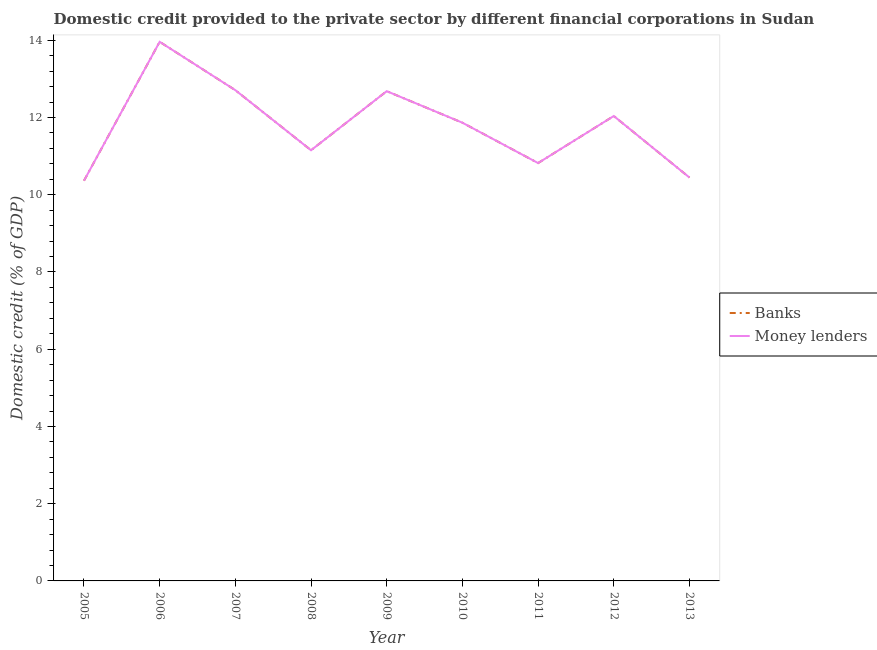How many different coloured lines are there?
Provide a short and direct response. 2. Is the number of lines equal to the number of legend labels?
Give a very brief answer. Yes. What is the domestic credit provided by banks in 2007?
Your answer should be very brief. 12.71. Across all years, what is the maximum domestic credit provided by money lenders?
Your answer should be compact. 13.96. Across all years, what is the minimum domestic credit provided by banks?
Your response must be concise. 10.36. In which year was the domestic credit provided by banks maximum?
Your answer should be very brief. 2006. What is the total domestic credit provided by money lenders in the graph?
Your response must be concise. 106.04. What is the difference between the domestic credit provided by money lenders in 2008 and that in 2012?
Make the answer very short. -0.89. What is the difference between the domestic credit provided by money lenders in 2009 and the domestic credit provided by banks in 2007?
Ensure brevity in your answer.  -0.03. What is the average domestic credit provided by banks per year?
Give a very brief answer. 11.78. In how many years, is the domestic credit provided by money lenders greater than 13.2 %?
Provide a succinct answer. 1. What is the ratio of the domestic credit provided by banks in 2005 to that in 2013?
Provide a short and direct response. 0.99. Is the difference between the domestic credit provided by banks in 2005 and 2013 greater than the difference between the domestic credit provided by money lenders in 2005 and 2013?
Provide a short and direct response. No. What is the difference between the highest and the second highest domestic credit provided by banks?
Make the answer very short. 1.25. What is the difference between the highest and the lowest domestic credit provided by banks?
Ensure brevity in your answer.  3.6. Is the sum of the domestic credit provided by money lenders in 2005 and 2011 greater than the maximum domestic credit provided by banks across all years?
Your answer should be very brief. Yes. Does the domestic credit provided by banks monotonically increase over the years?
Your response must be concise. No. Is the domestic credit provided by banks strictly greater than the domestic credit provided by money lenders over the years?
Offer a terse response. No. Is the domestic credit provided by banks strictly less than the domestic credit provided by money lenders over the years?
Provide a succinct answer. No. How many years are there in the graph?
Your response must be concise. 9. What is the difference between two consecutive major ticks on the Y-axis?
Give a very brief answer. 2. Does the graph contain any zero values?
Offer a terse response. No. Does the graph contain grids?
Make the answer very short. No. Where does the legend appear in the graph?
Offer a very short reply. Center right. What is the title of the graph?
Your answer should be very brief. Domestic credit provided to the private sector by different financial corporations in Sudan. Does "Methane emissions" appear as one of the legend labels in the graph?
Offer a terse response. No. What is the label or title of the Y-axis?
Offer a terse response. Domestic credit (% of GDP). What is the Domestic credit (% of GDP) in Banks in 2005?
Ensure brevity in your answer.  10.36. What is the Domestic credit (% of GDP) in Money lenders in 2005?
Keep it short and to the point. 10.36. What is the Domestic credit (% of GDP) of Banks in 2006?
Ensure brevity in your answer.  13.96. What is the Domestic credit (% of GDP) in Money lenders in 2006?
Provide a succinct answer. 13.96. What is the Domestic credit (% of GDP) of Banks in 2007?
Your response must be concise. 12.71. What is the Domestic credit (% of GDP) of Money lenders in 2007?
Ensure brevity in your answer.  12.71. What is the Domestic credit (% of GDP) of Banks in 2008?
Provide a succinct answer. 11.15. What is the Domestic credit (% of GDP) of Money lenders in 2008?
Provide a short and direct response. 11.15. What is the Domestic credit (% of GDP) of Banks in 2009?
Your response must be concise. 12.68. What is the Domestic credit (% of GDP) of Money lenders in 2009?
Provide a short and direct response. 12.68. What is the Domestic credit (% of GDP) in Banks in 2010?
Offer a terse response. 11.87. What is the Domestic credit (% of GDP) in Money lenders in 2010?
Offer a very short reply. 11.87. What is the Domestic credit (% of GDP) of Banks in 2011?
Your response must be concise. 10.82. What is the Domestic credit (% of GDP) in Money lenders in 2011?
Make the answer very short. 10.82. What is the Domestic credit (% of GDP) of Banks in 2012?
Keep it short and to the point. 12.04. What is the Domestic credit (% of GDP) of Money lenders in 2012?
Your answer should be very brief. 12.04. What is the Domestic credit (% of GDP) in Banks in 2013?
Offer a terse response. 10.45. What is the Domestic credit (% of GDP) in Money lenders in 2013?
Make the answer very short. 10.45. Across all years, what is the maximum Domestic credit (% of GDP) of Banks?
Make the answer very short. 13.96. Across all years, what is the maximum Domestic credit (% of GDP) in Money lenders?
Make the answer very short. 13.96. Across all years, what is the minimum Domestic credit (% of GDP) in Banks?
Your response must be concise. 10.36. Across all years, what is the minimum Domestic credit (% of GDP) of Money lenders?
Offer a terse response. 10.36. What is the total Domestic credit (% of GDP) of Banks in the graph?
Ensure brevity in your answer.  106.04. What is the total Domestic credit (% of GDP) of Money lenders in the graph?
Offer a very short reply. 106.04. What is the difference between the Domestic credit (% of GDP) in Banks in 2005 and that in 2006?
Your response must be concise. -3.6. What is the difference between the Domestic credit (% of GDP) of Money lenders in 2005 and that in 2006?
Offer a very short reply. -3.6. What is the difference between the Domestic credit (% of GDP) of Banks in 2005 and that in 2007?
Your answer should be compact. -2.34. What is the difference between the Domestic credit (% of GDP) of Money lenders in 2005 and that in 2007?
Offer a very short reply. -2.34. What is the difference between the Domestic credit (% of GDP) of Banks in 2005 and that in 2008?
Your answer should be very brief. -0.79. What is the difference between the Domestic credit (% of GDP) of Money lenders in 2005 and that in 2008?
Give a very brief answer. -0.79. What is the difference between the Domestic credit (% of GDP) of Banks in 2005 and that in 2009?
Give a very brief answer. -2.32. What is the difference between the Domestic credit (% of GDP) of Money lenders in 2005 and that in 2009?
Your response must be concise. -2.32. What is the difference between the Domestic credit (% of GDP) of Banks in 2005 and that in 2010?
Make the answer very short. -1.5. What is the difference between the Domestic credit (% of GDP) of Money lenders in 2005 and that in 2010?
Keep it short and to the point. -1.5. What is the difference between the Domestic credit (% of GDP) in Banks in 2005 and that in 2011?
Keep it short and to the point. -0.46. What is the difference between the Domestic credit (% of GDP) of Money lenders in 2005 and that in 2011?
Keep it short and to the point. -0.46. What is the difference between the Domestic credit (% of GDP) of Banks in 2005 and that in 2012?
Ensure brevity in your answer.  -1.68. What is the difference between the Domestic credit (% of GDP) of Money lenders in 2005 and that in 2012?
Ensure brevity in your answer.  -1.68. What is the difference between the Domestic credit (% of GDP) in Banks in 2005 and that in 2013?
Make the answer very short. -0.08. What is the difference between the Domestic credit (% of GDP) in Money lenders in 2005 and that in 2013?
Offer a very short reply. -0.08. What is the difference between the Domestic credit (% of GDP) of Banks in 2006 and that in 2007?
Your answer should be compact. 1.25. What is the difference between the Domestic credit (% of GDP) of Money lenders in 2006 and that in 2007?
Your response must be concise. 1.25. What is the difference between the Domestic credit (% of GDP) in Banks in 2006 and that in 2008?
Offer a terse response. 2.81. What is the difference between the Domestic credit (% of GDP) in Money lenders in 2006 and that in 2008?
Ensure brevity in your answer.  2.81. What is the difference between the Domestic credit (% of GDP) of Banks in 2006 and that in 2009?
Keep it short and to the point. 1.28. What is the difference between the Domestic credit (% of GDP) in Money lenders in 2006 and that in 2009?
Your answer should be compact. 1.28. What is the difference between the Domestic credit (% of GDP) in Banks in 2006 and that in 2010?
Give a very brief answer. 2.09. What is the difference between the Domestic credit (% of GDP) of Money lenders in 2006 and that in 2010?
Provide a short and direct response. 2.09. What is the difference between the Domestic credit (% of GDP) in Banks in 2006 and that in 2011?
Your response must be concise. 3.14. What is the difference between the Domestic credit (% of GDP) of Money lenders in 2006 and that in 2011?
Keep it short and to the point. 3.14. What is the difference between the Domestic credit (% of GDP) in Banks in 2006 and that in 2012?
Your response must be concise. 1.92. What is the difference between the Domestic credit (% of GDP) in Money lenders in 2006 and that in 2012?
Offer a very short reply. 1.92. What is the difference between the Domestic credit (% of GDP) of Banks in 2006 and that in 2013?
Make the answer very short. 3.51. What is the difference between the Domestic credit (% of GDP) of Money lenders in 2006 and that in 2013?
Provide a short and direct response. 3.51. What is the difference between the Domestic credit (% of GDP) in Banks in 2007 and that in 2008?
Provide a short and direct response. 1.56. What is the difference between the Domestic credit (% of GDP) of Money lenders in 2007 and that in 2008?
Provide a succinct answer. 1.56. What is the difference between the Domestic credit (% of GDP) of Banks in 2007 and that in 2009?
Offer a terse response. 0.03. What is the difference between the Domestic credit (% of GDP) of Money lenders in 2007 and that in 2009?
Provide a short and direct response. 0.03. What is the difference between the Domestic credit (% of GDP) of Banks in 2007 and that in 2010?
Ensure brevity in your answer.  0.84. What is the difference between the Domestic credit (% of GDP) in Money lenders in 2007 and that in 2010?
Ensure brevity in your answer.  0.84. What is the difference between the Domestic credit (% of GDP) of Banks in 2007 and that in 2011?
Provide a succinct answer. 1.89. What is the difference between the Domestic credit (% of GDP) of Money lenders in 2007 and that in 2011?
Provide a short and direct response. 1.89. What is the difference between the Domestic credit (% of GDP) in Banks in 2007 and that in 2012?
Provide a short and direct response. 0.67. What is the difference between the Domestic credit (% of GDP) in Money lenders in 2007 and that in 2012?
Offer a terse response. 0.67. What is the difference between the Domestic credit (% of GDP) of Banks in 2007 and that in 2013?
Offer a terse response. 2.26. What is the difference between the Domestic credit (% of GDP) of Money lenders in 2007 and that in 2013?
Offer a very short reply. 2.26. What is the difference between the Domestic credit (% of GDP) in Banks in 2008 and that in 2009?
Your response must be concise. -1.53. What is the difference between the Domestic credit (% of GDP) in Money lenders in 2008 and that in 2009?
Offer a terse response. -1.53. What is the difference between the Domestic credit (% of GDP) of Banks in 2008 and that in 2010?
Make the answer very short. -0.71. What is the difference between the Domestic credit (% of GDP) of Money lenders in 2008 and that in 2010?
Your answer should be very brief. -0.71. What is the difference between the Domestic credit (% of GDP) in Banks in 2008 and that in 2011?
Make the answer very short. 0.33. What is the difference between the Domestic credit (% of GDP) of Money lenders in 2008 and that in 2011?
Keep it short and to the point. 0.33. What is the difference between the Domestic credit (% of GDP) in Banks in 2008 and that in 2012?
Your answer should be very brief. -0.89. What is the difference between the Domestic credit (% of GDP) of Money lenders in 2008 and that in 2012?
Offer a terse response. -0.89. What is the difference between the Domestic credit (% of GDP) of Banks in 2008 and that in 2013?
Provide a short and direct response. 0.71. What is the difference between the Domestic credit (% of GDP) of Money lenders in 2008 and that in 2013?
Your answer should be very brief. 0.71. What is the difference between the Domestic credit (% of GDP) of Banks in 2009 and that in 2010?
Make the answer very short. 0.82. What is the difference between the Domestic credit (% of GDP) of Money lenders in 2009 and that in 2010?
Provide a succinct answer. 0.82. What is the difference between the Domestic credit (% of GDP) in Banks in 2009 and that in 2011?
Your answer should be very brief. 1.86. What is the difference between the Domestic credit (% of GDP) in Money lenders in 2009 and that in 2011?
Your answer should be very brief. 1.86. What is the difference between the Domestic credit (% of GDP) of Banks in 2009 and that in 2012?
Your response must be concise. 0.64. What is the difference between the Domestic credit (% of GDP) in Money lenders in 2009 and that in 2012?
Make the answer very short. 0.64. What is the difference between the Domestic credit (% of GDP) of Banks in 2009 and that in 2013?
Provide a short and direct response. 2.24. What is the difference between the Domestic credit (% of GDP) in Money lenders in 2009 and that in 2013?
Your answer should be very brief. 2.24. What is the difference between the Domestic credit (% of GDP) of Banks in 2010 and that in 2011?
Your response must be concise. 1.04. What is the difference between the Domestic credit (% of GDP) of Money lenders in 2010 and that in 2011?
Give a very brief answer. 1.04. What is the difference between the Domestic credit (% of GDP) of Banks in 2010 and that in 2012?
Give a very brief answer. -0.17. What is the difference between the Domestic credit (% of GDP) in Money lenders in 2010 and that in 2012?
Make the answer very short. -0.17. What is the difference between the Domestic credit (% of GDP) of Banks in 2010 and that in 2013?
Keep it short and to the point. 1.42. What is the difference between the Domestic credit (% of GDP) of Money lenders in 2010 and that in 2013?
Keep it short and to the point. 1.42. What is the difference between the Domestic credit (% of GDP) in Banks in 2011 and that in 2012?
Provide a short and direct response. -1.22. What is the difference between the Domestic credit (% of GDP) in Money lenders in 2011 and that in 2012?
Offer a terse response. -1.22. What is the difference between the Domestic credit (% of GDP) in Banks in 2011 and that in 2013?
Offer a very short reply. 0.37. What is the difference between the Domestic credit (% of GDP) of Money lenders in 2011 and that in 2013?
Provide a short and direct response. 0.37. What is the difference between the Domestic credit (% of GDP) in Banks in 2012 and that in 2013?
Provide a short and direct response. 1.59. What is the difference between the Domestic credit (% of GDP) in Money lenders in 2012 and that in 2013?
Offer a very short reply. 1.59. What is the difference between the Domestic credit (% of GDP) of Banks in 2005 and the Domestic credit (% of GDP) of Money lenders in 2006?
Give a very brief answer. -3.6. What is the difference between the Domestic credit (% of GDP) of Banks in 2005 and the Domestic credit (% of GDP) of Money lenders in 2007?
Offer a very short reply. -2.34. What is the difference between the Domestic credit (% of GDP) of Banks in 2005 and the Domestic credit (% of GDP) of Money lenders in 2008?
Make the answer very short. -0.79. What is the difference between the Domestic credit (% of GDP) in Banks in 2005 and the Domestic credit (% of GDP) in Money lenders in 2009?
Make the answer very short. -2.32. What is the difference between the Domestic credit (% of GDP) of Banks in 2005 and the Domestic credit (% of GDP) of Money lenders in 2010?
Ensure brevity in your answer.  -1.5. What is the difference between the Domestic credit (% of GDP) in Banks in 2005 and the Domestic credit (% of GDP) in Money lenders in 2011?
Your response must be concise. -0.46. What is the difference between the Domestic credit (% of GDP) of Banks in 2005 and the Domestic credit (% of GDP) of Money lenders in 2012?
Offer a terse response. -1.68. What is the difference between the Domestic credit (% of GDP) of Banks in 2005 and the Domestic credit (% of GDP) of Money lenders in 2013?
Give a very brief answer. -0.08. What is the difference between the Domestic credit (% of GDP) in Banks in 2006 and the Domestic credit (% of GDP) in Money lenders in 2007?
Your answer should be compact. 1.25. What is the difference between the Domestic credit (% of GDP) of Banks in 2006 and the Domestic credit (% of GDP) of Money lenders in 2008?
Your response must be concise. 2.81. What is the difference between the Domestic credit (% of GDP) in Banks in 2006 and the Domestic credit (% of GDP) in Money lenders in 2009?
Your answer should be very brief. 1.28. What is the difference between the Domestic credit (% of GDP) in Banks in 2006 and the Domestic credit (% of GDP) in Money lenders in 2010?
Give a very brief answer. 2.09. What is the difference between the Domestic credit (% of GDP) in Banks in 2006 and the Domestic credit (% of GDP) in Money lenders in 2011?
Offer a very short reply. 3.14. What is the difference between the Domestic credit (% of GDP) of Banks in 2006 and the Domestic credit (% of GDP) of Money lenders in 2012?
Your response must be concise. 1.92. What is the difference between the Domestic credit (% of GDP) of Banks in 2006 and the Domestic credit (% of GDP) of Money lenders in 2013?
Keep it short and to the point. 3.51. What is the difference between the Domestic credit (% of GDP) in Banks in 2007 and the Domestic credit (% of GDP) in Money lenders in 2008?
Ensure brevity in your answer.  1.56. What is the difference between the Domestic credit (% of GDP) in Banks in 2007 and the Domestic credit (% of GDP) in Money lenders in 2009?
Ensure brevity in your answer.  0.03. What is the difference between the Domestic credit (% of GDP) of Banks in 2007 and the Domestic credit (% of GDP) of Money lenders in 2010?
Your answer should be very brief. 0.84. What is the difference between the Domestic credit (% of GDP) in Banks in 2007 and the Domestic credit (% of GDP) in Money lenders in 2011?
Your response must be concise. 1.89. What is the difference between the Domestic credit (% of GDP) of Banks in 2007 and the Domestic credit (% of GDP) of Money lenders in 2012?
Your response must be concise. 0.67. What is the difference between the Domestic credit (% of GDP) in Banks in 2007 and the Domestic credit (% of GDP) in Money lenders in 2013?
Provide a short and direct response. 2.26. What is the difference between the Domestic credit (% of GDP) in Banks in 2008 and the Domestic credit (% of GDP) in Money lenders in 2009?
Offer a very short reply. -1.53. What is the difference between the Domestic credit (% of GDP) of Banks in 2008 and the Domestic credit (% of GDP) of Money lenders in 2010?
Your answer should be compact. -0.71. What is the difference between the Domestic credit (% of GDP) of Banks in 2008 and the Domestic credit (% of GDP) of Money lenders in 2011?
Keep it short and to the point. 0.33. What is the difference between the Domestic credit (% of GDP) of Banks in 2008 and the Domestic credit (% of GDP) of Money lenders in 2012?
Offer a terse response. -0.89. What is the difference between the Domestic credit (% of GDP) of Banks in 2008 and the Domestic credit (% of GDP) of Money lenders in 2013?
Give a very brief answer. 0.71. What is the difference between the Domestic credit (% of GDP) in Banks in 2009 and the Domestic credit (% of GDP) in Money lenders in 2010?
Offer a terse response. 0.82. What is the difference between the Domestic credit (% of GDP) in Banks in 2009 and the Domestic credit (% of GDP) in Money lenders in 2011?
Provide a succinct answer. 1.86. What is the difference between the Domestic credit (% of GDP) of Banks in 2009 and the Domestic credit (% of GDP) of Money lenders in 2012?
Provide a succinct answer. 0.64. What is the difference between the Domestic credit (% of GDP) of Banks in 2009 and the Domestic credit (% of GDP) of Money lenders in 2013?
Your answer should be very brief. 2.24. What is the difference between the Domestic credit (% of GDP) in Banks in 2010 and the Domestic credit (% of GDP) in Money lenders in 2011?
Keep it short and to the point. 1.04. What is the difference between the Domestic credit (% of GDP) of Banks in 2010 and the Domestic credit (% of GDP) of Money lenders in 2012?
Provide a short and direct response. -0.17. What is the difference between the Domestic credit (% of GDP) in Banks in 2010 and the Domestic credit (% of GDP) in Money lenders in 2013?
Keep it short and to the point. 1.42. What is the difference between the Domestic credit (% of GDP) of Banks in 2011 and the Domestic credit (% of GDP) of Money lenders in 2012?
Provide a succinct answer. -1.22. What is the difference between the Domestic credit (% of GDP) in Banks in 2011 and the Domestic credit (% of GDP) in Money lenders in 2013?
Your answer should be compact. 0.37. What is the difference between the Domestic credit (% of GDP) of Banks in 2012 and the Domestic credit (% of GDP) of Money lenders in 2013?
Offer a very short reply. 1.59. What is the average Domestic credit (% of GDP) in Banks per year?
Your response must be concise. 11.78. What is the average Domestic credit (% of GDP) in Money lenders per year?
Provide a short and direct response. 11.78. In the year 2005, what is the difference between the Domestic credit (% of GDP) in Banks and Domestic credit (% of GDP) in Money lenders?
Your answer should be compact. 0. In the year 2007, what is the difference between the Domestic credit (% of GDP) of Banks and Domestic credit (% of GDP) of Money lenders?
Ensure brevity in your answer.  0. In the year 2008, what is the difference between the Domestic credit (% of GDP) in Banks and Domestic credit (% of GDP) in Money lenders?
Your answer should be very brief. 0. In the year 2011, what is the difference between the Domestic credit (% of GDP) in Banks and Domestic credit (% of GDP) in Money lenders?
Ensure brevity in your answer.  0. What is the ratio of the Domestic credit (% of GDP) of Banks in 2005 to that in 2006?
Provide a short and direct response. 0.74. What is the ratio of the Domestic credit (% of GDP) in Money lenders in 2005 to that in 2006?
Give a very brief answer. 0.74. What is the ratio of the Domestic credit (% of GDP) in Banks in 2005 to that in 2007?
Ensure brevity in your answer.  0.82. What is the ratio of the Domestic credit (% of GDP) in Money lenders in 2005 to that in 2007?
Your answer should be very brief. 0.82. What is the ratio of the Domestic credit (% of GDP) of Banks in 2005 to that in 2008?
Your answer should be very brief. 0.93. What is the ratio of the Domestic credit (% of GDP) of Money lenders in 2005 to that in 2008?
Your answer should be very brief. 0.93. What is the ratio of the Domestic credit (% of GDP) of Banks in 2005 to that in 2009?
Your response must be concise. 0.82. What is the ratio of the Domestic credit (% of GDP) in Money lenders in 2005 to that in 2009?
Your answer should be very brief. 0.82. What is the ratio of the Domestic credit (% of GDP) of Banks in 2005 to that in 2010?
Make the answer very short. 0.87. What is the ratio of the Domestic credit (% of GDP) in Money lenders in 2005 to that in 2010?
Your response must be concise. 0.87. What is the ratio of the Domestic credit (% of GDP) of Banks in 2005 to that in 2011?
Make the answer very short. 0.96. What is the ratio of the Domestic credit (% of GDP) of Money lenders in 2005 to that in 2011?
Provide a succinct answer. 0.96. What is the ratio of the Domestic credit (% of GDP) in Banks in 2005 to that in 2012?
Give a very brief answer. 0.86. What is the ratio of the Domestic credit (% of GDP) of Money lenders in 2005 to that in 2012?
Make the answer very short. 0.86. What is the ratio of the Domestic credit (% of GDP) in Money lenders in 2005 to that in 2013?
Make the answer very short. 0.99. What is the ratio of the Domestic credit (% of GDP) in Banks in 2006 to that in 2007?
Keep it short and to the point. 1.1. What is the ratio of the Domestic credit (% of GDP) in Money lenders in 2006 to that in 2007?
Provide a short and direct response. 1.1. What is the ratio of the Domestic credit (% of GDP) in Banks in 2006 to that in 2008?
Keep it short and to the point. 1.25. What is the ratio of the Domestic credit (% of GDP) in Money lenders in 2006 to that in 2008?
Keep it short and to the point. 1.25. What is the ratio of the Domestic credit (% of GDP) in Banks in 2006 to that in 2009?
Give a very brief answer. 1.1. What is the ratio of the Domestic credit (% of GDP) in Money lenders in 2006 to that in 2009?
Give a very brief answer. 1.1. What is the ratio of the Domestic credit (% of GDP) of Banks in 2006 to that in 2010?
Provide a short and direct response. 1.18. What is the ratio of the Domestic credit (% of GDP) in Money lenders in 2006 to that in 2010?
Your answer should be very brief. 1.18. What is the ratio of the Domestic credit (% of GDP) in Banks in 2006 to that in 2011?
Keep it short and to the point. 1.29. What is the ratio of the Domestic credit (% of GDP) of Money lenders in 2006 to that in 2011?
Your answer should be very brief. 1.29. What is the ratio of the Domestic credit (% of GDP) in Banks in 2006 to that in 2012?
Your response must be concise. 1.16. What is the ratio of the Domestic credit (% of GDP) of Money lenders in 2006 to that in 2012?
Give a very brief answer. 1.16. What is the ratio of the Domestic credit (% of GDP) of Banks in 2006 to that in 2013?
Keep it short and to the point. 1.34. What is the ratio of the Domestic credit (% of GDP) in Money lenders in 2006 to that in 2013?
Offer a very short reply. 1.34. What is the ratio of the Domestic credit (% of GDP) in Banks in 2007 to that in 2008?
Your answer should be compact. 1.14. What is the ratio of the Domestic credit (% of GDP) of Money lenders in 2007 to that in 2008?
Provide a short and direct response. 1.14. What is the ratio of the Domestic credit (% of GDP) of Money lenders in 2007 to that in 2009?
Give a very brief answer. 1. What is the ratio of the Domestic credit (% of GDP) in Banks in 2007 to that in 2010?
Your answer should be very brief. 1.07. What is the ratio of the Domestic credit (% of GDP) in Money lenders in 2007 to that in 2010?
Provide a short and direct response. 1.07. What is the ratio of the Domestic credit (% of GDP) of Banks in 2007 to that in 2011?
Ensure brevity in your answer.  1.17. What is the ratio of the Domestic credit (% of GDP) of Money lenders in 2007 to that in 2011?
Provide a short and direct response. 1.17. What is the ratio of the Domestic credit (% of GDP) of Banks in 2007 to that in 2012?
Offer a very short reply. 1.06. What is the ratio of the Domestic credit (% of GDP) in Money lenders in 2007 to that in 2012?
Keep it short and to the point. 1.06. What is the ratio of the Domestic credit (% of GDP) in Banks in 2007 to that in 2013?
Your response must be concise. 1.22. What is the ratio of the Domestic credit (% of GDP) in Money lenders in 2007 to that in 2013?
Your answer should be compact. 1.22. What is the ratio of the Domestic credit (% of GDP) of Banks in 2008 to that in 2009?
Your answer should be very brief. 0.88. What is the ratio of the Domestic credit (% of GDP) of Money lenders in 2008 to that in 2009?
Keep it short and to the point. 0.88. What is the ratio of the Domestic credit (% of GDP) in Banks in 2008 to that in 2010?
Offer a very short reply. 0.94. What is the ratio of the Domestic credit (% of GDP) in Money lenders in 2008 to that in 2010?
Offer a very short reply. 0.94. What is the ratio of the Domestic credit (% of GDP) in Banks in 2008 to that in 2011?
Offer a very short reply. 1.03. What is the ratio of the Domestic credit (% of GDP) in Money lenders in 2008 to that in 2011?
Keep it short and to the point. 1.03. What is the ratio of the Domestic credit (% of GDP) of Banks in 2008 to that in 2012?
Your answer should be very brief. 0.93. What is the ratio of the Domestic credit (% of GDP) in Money lenders in 2008 to that in 2012?
Offer a very short reply. 0.93. What is the ratio of the Domestic credit (% of GDP) of Banks in 2008 to that in 2013?
Your answer should be compact. 1.07. What is the ratio of the Domestic credit (% of GDP) in Money lenders in 2008 to that in 2013?
Offer a very short reply. 1.07. What is the ratio of the Domestic credit (% of GDP) in Banks in 2009 to that in 2010?
Give a very brief answer. 1.07. What is the ratio of the Domestic credit (% of GDP) in Money lenders in 2009 to that in 2010?
Ensure brevity in your answer.  1.07. What is the ratio of the Domestic credit (% of GDP) in Banks in 2009 to that in 2011?
Give a very brief answer. 1.17. What is the ratio of the Domestic credit (% of GDP) in Money lenders in 2009 to that in 2011?
Your answer should be very brief. 1.17. What is the ratio of the Domestic credit (% of GDP) in Banks in 2009 to that in 2012?
Your answer should be compact. 1.05. What is the ratio of the Domestic credit (% of GDP) of Money lenders in 2009 to that in 2012?
Your answer should be very brief. 1.05. What is the ratio of the Domestic credit (% of GDP) of Banks in 2009 to that in 2013?
Offer a very short reply. 1.21. What is the ratio of the Domestic credit (% of GDP) in Money lenders in 2009 to that in 2013?
Provide a succinct answer. 1.21. What is the ratio of the Domestic credit (% of GDP) in Banks in 2010 to that in 2011?
Your answer should be compact. 1.1. What is the ratio of the Domestic credit (% of GDP) of Money lenders in 2010 to that in 2011?
Your answer should be compact. 1.1. What is the ratio of the Domestic credit (% of GDP) of Banks in 2010 to that in 2012?
Offer a terse response. 0.99. What is the ratio of the Domestic credit (% of GDP) in Money lenders in 2010 to that in 2012?
Provide a short and direct response. 0.99. What is the ratio of the Domestic credit (% of GDP) of Banks in 2010 to that in 2013?
Ensure brevity in your answer.  1.14. What is the ratio of the Domestic credit (% of GDP) of Money lenders in 2010 to that in 2013?
Your answer should be very brief. 1.14. What is the ratio of the Domestic credit (% of GDP) of Banks in 2011 to that in 2012?
Your answer should be very brief. 0.9. What is the ratio of the Domestic credit (% of GDP) of Money lenders in 2011 to that in 2012?
Ensure brevity in your answer.  0.9. What is the ratio of the Domestic credit (% of GDP) in Banks in 2011 to that in 2013?
Give a very brief answer. 1.04. What is the ratio of the Domestic credit (% of GDP) in Money lenders in 2011 to that in 2013?
Ensure brevity in your answer.  1.04. What is the ratio of the Domestic credit (% of GDP) of Banks in 2012 to that in 2013?
Your response must be concise. 1.15. What is the ratio of the Domestic credit (% of GDP) in Money lenders in 2012 to that in 2013?
Your answer should be compact. 1.15. What is the difference between the highest and the second highest Domestic credit (% of GDP) of Banks?
Your answer should be compact. 1.25. What is the difference between the highest and the second highest Domestic credit (% of GDP) in Money lenders?
Offer a very short reply. 1.25. What is the difference between the highest and the lowest Domestic credit (% of GDP) in Banks?
Ensure brevity in your answer.  3.6. What is the difference between the highest and the lowest Domestic credit (% of GDP) of Money lenders?
Provide a short and direct response. 3.6. 